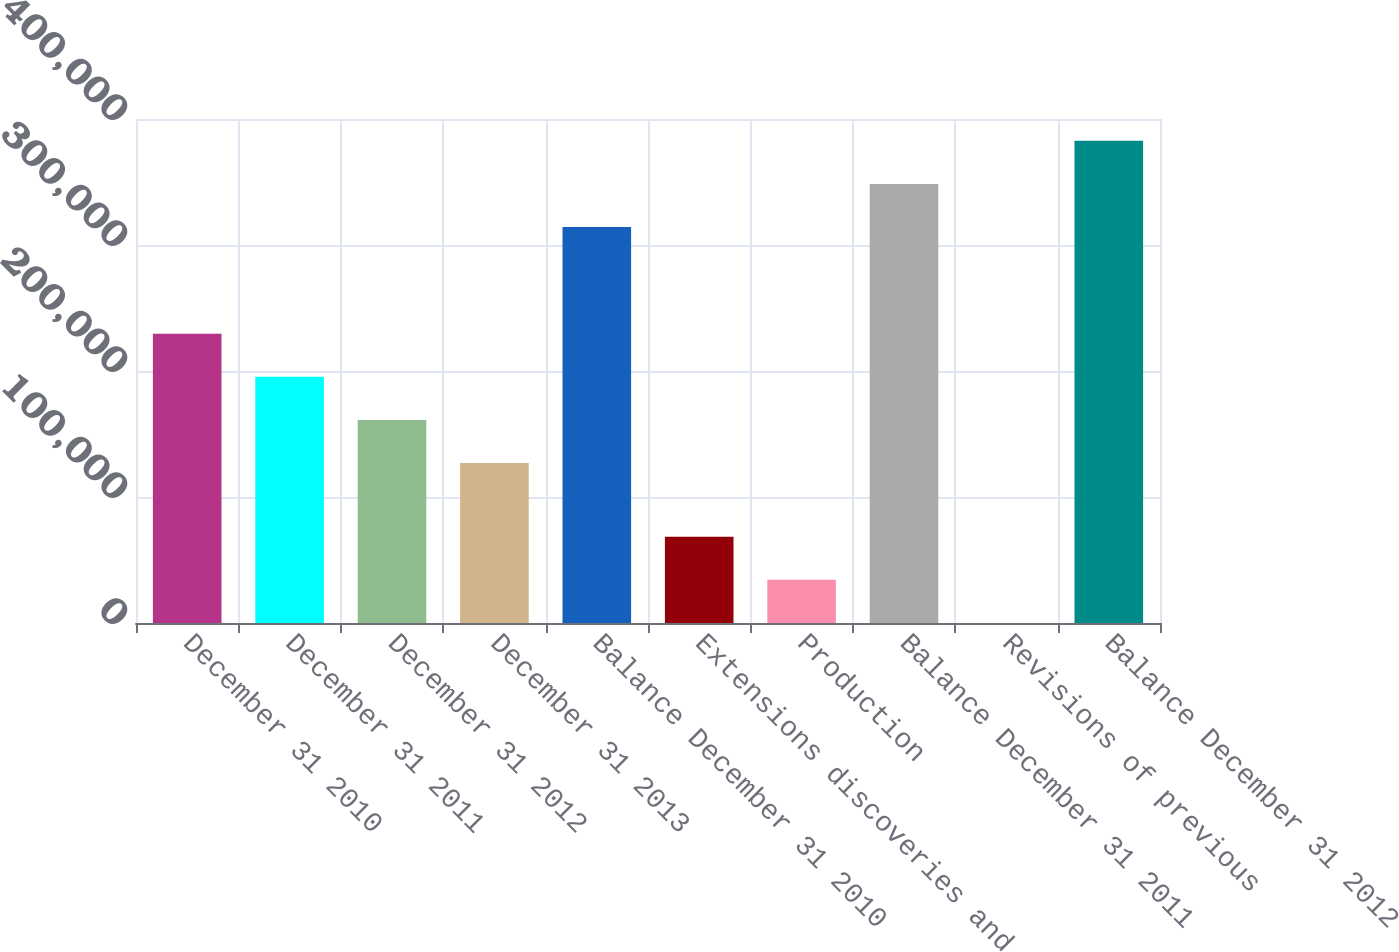<chart> <loc_0><loc_0><loc_500><loc_500><bar_chart><fcel>December 31 2010<fcel>December 31 2011<fcel>December 31 2012<fcel>December 31 2013<fcel>Balance December 31 2010<fcel>Extensions discoveries and<fcel>Production<fcel>Balance December 31 2011<fcel>Revisions of previous<fcel>Balance December 31 2012<nl><fcel>229595<fcel>195379<fcel>161164<fcel>126948<fcel>314219<fcel>68480.4<fcel>34264.7<fcel>348435<fcel>49<fcel>382650<nl></chart> 